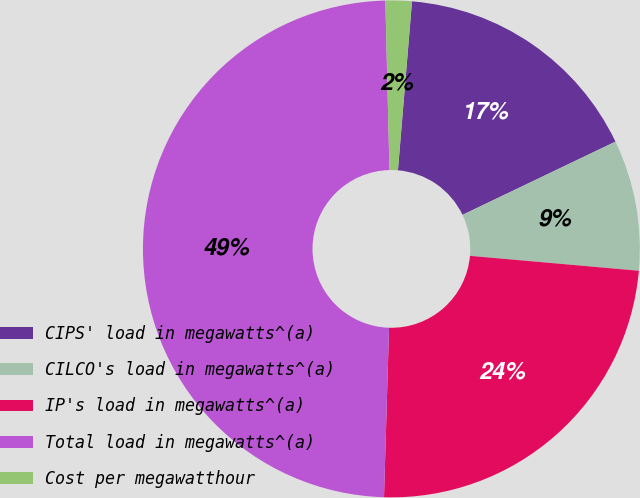Convert chart to OTSL. <chart><loc_0><loc_0><loc_500><loc_500><pie_chart><fcel>CIPS' load in megawatts^(a)<fcel>CILCO's load in megawatts^(a)<fcel>IP's load in megawatts^(a)<fcel>Total load in megawatts^(a)<fcel>Cost per megawatthour<nl><fcel>16.57%<fcel>8.51%<fcel>24.07%<fcel>49.14%<fcel>1.71%<nl></chart> 